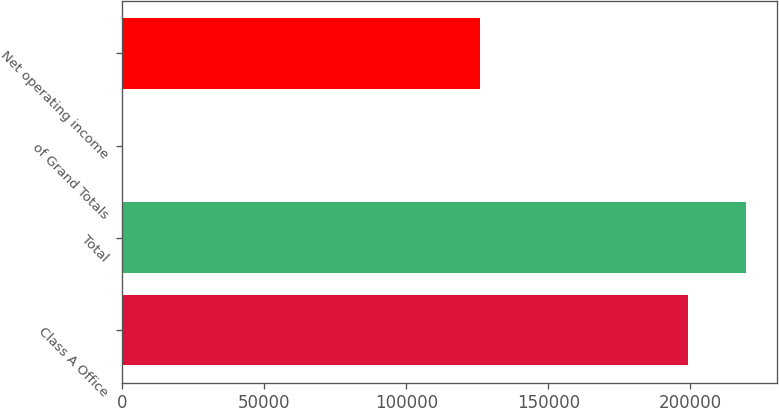Convert chart. <chart><loc_0><loc_0><loc_500><loc_500><bar_chart><fcel>Class A Office<fcel>Total<fcel>of Grand Totals<fcel>Net operating income<nl><fcel>199317<fcel>219415<fcel>15.91<fcel>125805<nl></chart> 